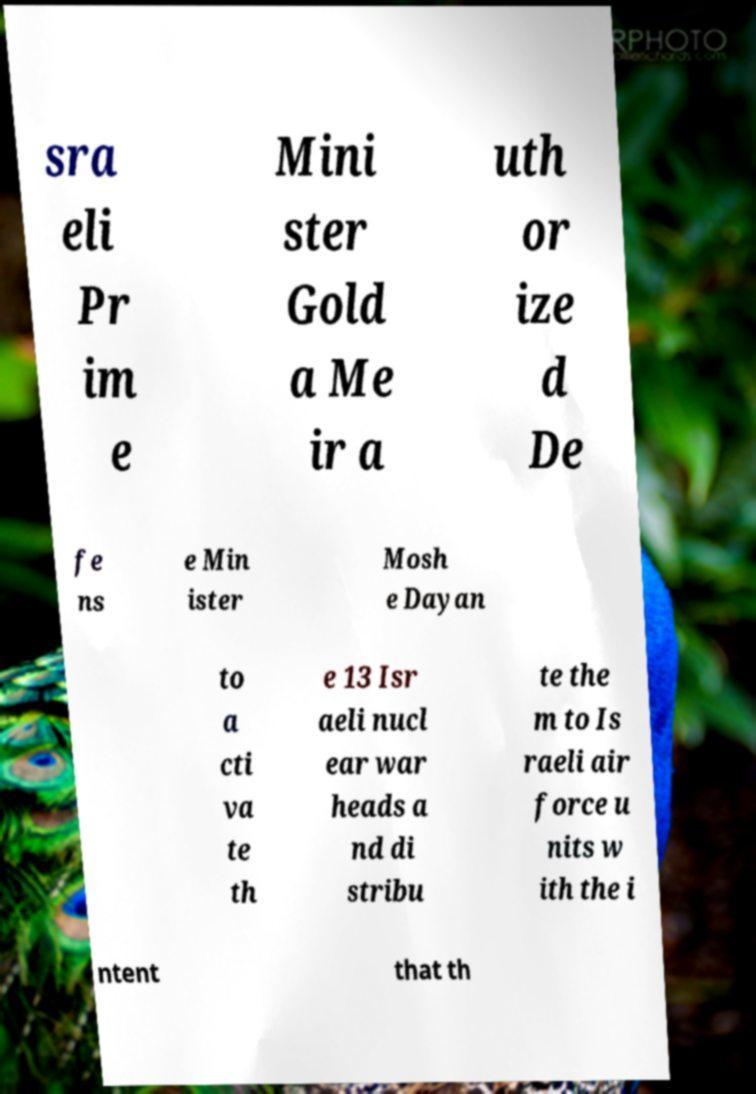Could you extract and type out the text from this image? sra eli Pr im e Mini ster Gold a Me ir a uth or ize d De fe ns e Min ister Mosh e Dayan to a cti va te th e 13 Isr aeli nucl ear war heads a nd di stribu te the m to Is raeli air force u nits w ith the i ntent that th 